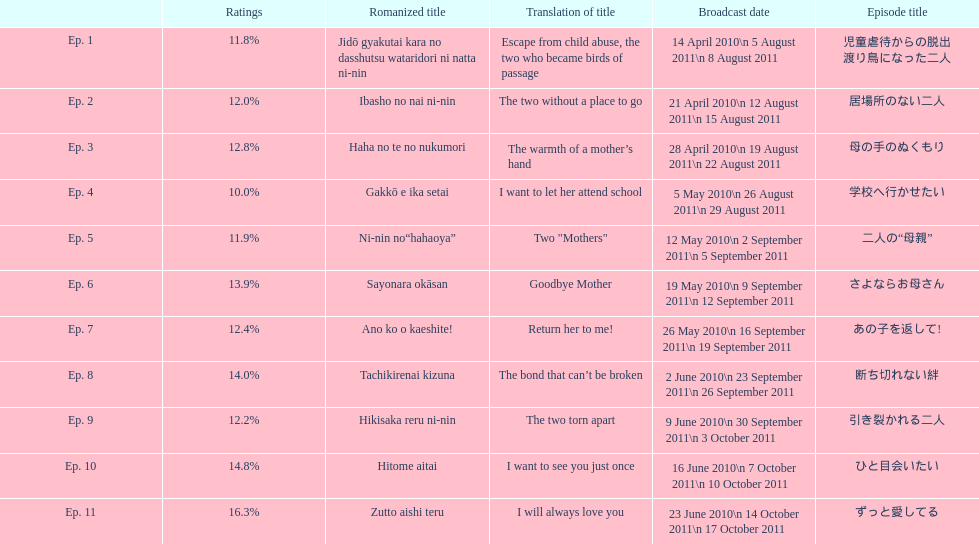What was the name of the next episode after goodbye mother? あの子を返して!. 